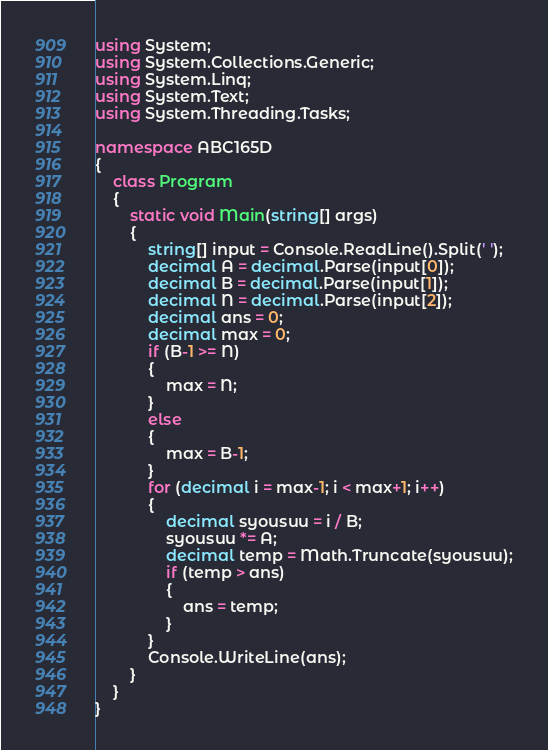<code> <loc_0><loc_0><loc_500><loc_500><_C#_>using System;
using System.Collections.Generic;
using System.Linq;
using System.Text;
using System.Threading.Tasks;

namespace ABC165D
{
    class Program
    {
        static void Main(string[] args)
        {
            string[] input = Console.ReadLine().Split(' ');
            decimal A = decimal.Parse(input[0]);
            decimal B = decimal.Parse(input[1]);
            decimal N = decimal.Parse(input[2]);
            decimal ans = 0;
            decimal max = 0;
            if (B-1 >= N)
            {
                max = N;
            }
            else
            {
                max = B-1;
            }
            for (decimal i = max-1; i < max+1; i++)
            {
                decimal syousuu = i / B;
                syousuu *= A;
                decimal temp = Math.Truncate(syousuu);
                if (temp > ans)
                {
                    ans = temp;
                }
            }
            Console.WriteLine(ans);
        }
    }
}
</code> 